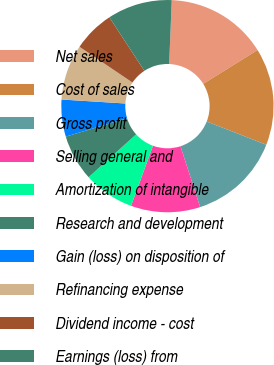<chart> <loc_0><loc_0><loc_500><loc_500><pie_chart><fcel>Net sales<fcel>Cost of sales<fcel>Gross profit<fcel>Selling general and<fcel>Amortization of intangible<fcel>Research and development<fcel>Gain (loss) on disposition of<fcel>Refinancing expense<fcel>Dividend income - cost<fcel>Earnings (loss) from<nl><fcel>15.49%<fcel>14.79%<fcel>14.08%<fcel>10.56%<fcel>7.75%<fcel>7.04%<fcel>5.63%<fcel>8.45%<fcel>6.34%<fcel>9.86%<nl></chart> 